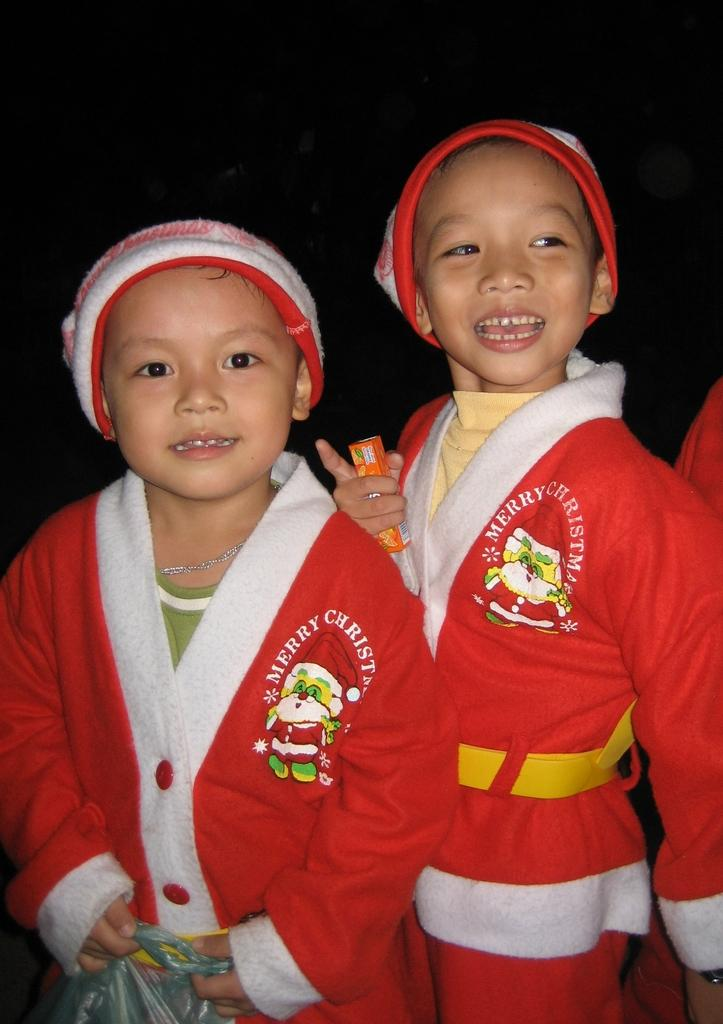<image>
Present a compact description of the photo's key features. Two young boys wearing red Merry Christmas sweaters 